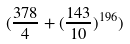Convert formula to latex. <formula><loc_0><loc_0><loc_500><loc_500>( \frac { 3 7 8 } { 4 } + ( \frac { 1 4 3 } { 1 0 } ) ^ { 1 9 6 } )</formula> 